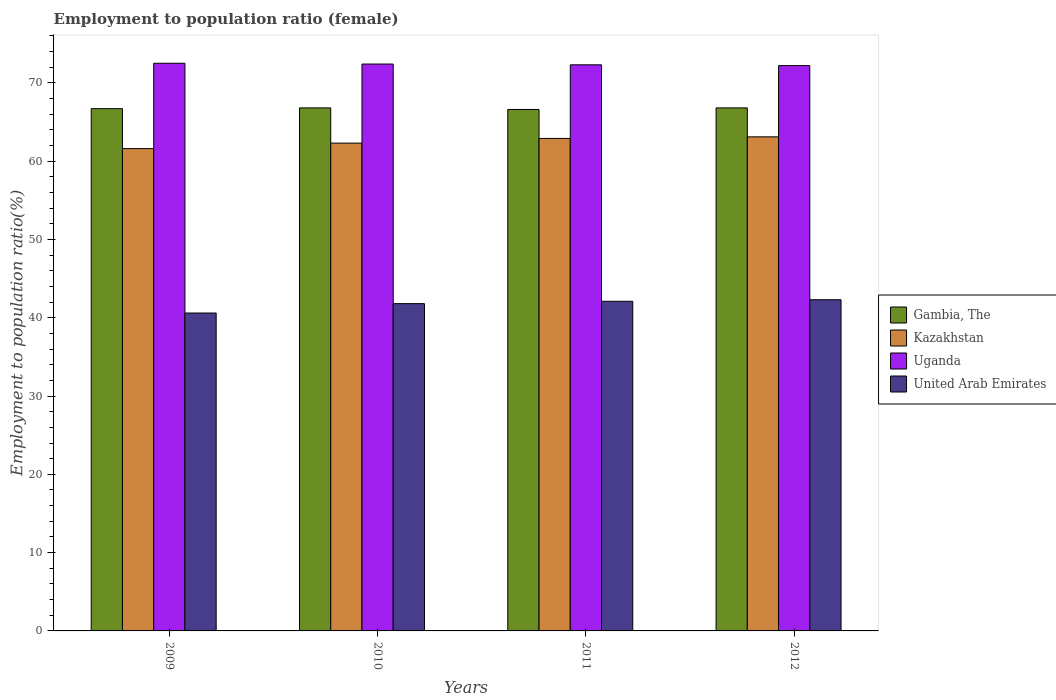How many different coloured bars are there?
Offer a very short reply. 4. Are the number of bars per tick equal to the number of legend labels?
Provide a succinct answer. Yes. Are the number of bars on each tick of the X-axis equal?
Provide a short and direct response. Yes. How many bars are there on the 2nd tick from the left?
Provide a short and direct response. 4. How many bars are there on the 4th tick from the right?
Provide a short and direct response. 4. What is the label of the 4th group of bars from the left?
Give a very brief answer. 2012. In how many cases, is the number of bars for a given year not equal to the number of legend labels?
Your answer should be very brief. 0. What is the employment to population ratio in United Arab Emirates in 2010?
Offer a very short reply. 41.8. Across all years, what is the maximum employment to population ratio in Uganda?
Provide a short and direct response. 72.5. Across all years, what is the minimum employment to population ratio in Kazakhstan?
Make the answer very short. 61.6. What is the total employment to population ratio in United Arab Emirates in the graph?
Your answer should be very brief. 166.8. What is the difference between the employment to population ratio in Kazakhstan in 2010 and that in 2012?
Make the answer very short. -0.8. What is the difference between the employment to population ratio in United Arab Emirates in 2009 and the employment to population ratio in Kazakhstan in 2012?
Provide a succinct answer. -22.5. What is the average employment to population ratio in Uganda per year?
Your response must be concise. 72.35. In the year 2011, what is the difference between the employment to population ratio in Gambia, The and employment to population ratio in Uganda?
Ensure brevity in your answer.  -5.7. In how many years, is the employment to population ratio in Uganda greater than 46 %?
Offer a terse response. 4. What is the ratio of the employment to population ratio in Gambia, The in 2009 to that in 2012?
Make the answer very short. 1. Is the difference between the employment to population ratio in Gambia, The in 2009 and 2011 greater than the difference between the employment to population ratio in Uganda in 2009 and 2011?
Provide a succinct answer. No. What is the difference between the highest and the second highest employment to population ratio in Uganda?
Ensure brevity in your answer.  0.1. What is the difference between the highest and the lowest employment to population ratio in United Arab Emirates?
Provide a short and direct response. 1.7. In how many years, is the employment to population ratio in United Arab Emirates greater than the average employment to population ratio in United Arab Emirates taken over all years?
Ensure brevity in your answer.  3. What does the 4th bar from the left in 2011 represents?
Your response must be concise. United Arab Emirates. What does the 4th bar from the right in 2012 represents?
Provide a short and direct response. Gambia, The. How many bars are there?
Your answer should be compact. 16. Are all the bars in the graph horizontal?
Make the answer very short. No. How many years are there in the graph?
Ensure brevity in your answer.  4. What is the difference between two consecutive major ticks on the Y-axis?
Make the answer very short. 10. Does the graph contain any zero values?
Provide a succinct answer. No. Does the graph contain grids?
Your answer should be very brief. No. Where does the legend appear in the graph?
Provide a short and direct response. Center right. How many legend labels are there?
Ensure brevity in your answer.  4. How are the legend labels stacked?
Make the answer very short. Vertical. What is the title of the graph?
Offer a terse response. Employment to population ratio (female). Does "Morocco" appear as one of the legend labels in the graph?
Offer a terse response. No. What is the Employment to population ratio(%) of Gambia, The in 2009?
Your answer should be very brief. 66.7. What is the Employment to population ratio(%) of Kazakhstan in 2009?
Offer a terse response. 61.6. What is the Employment to population ratio(%) of Uganda in 2009?
Your response must be concise. 72.5. What is the Employment to population ratio(%) of United Arab Emirates in 2009?
Give a very brief answer. 40.6. What is the Employment to population ratio(%) of Gambia, The in 2010?
Your answer should be compact. 66.8. What is the Employment to population ratio(%) of Kazakhstan in 2010?
Provide a succinct answer. 62.3. What is the Employment to population ratio(%) in Uganda in 2010?
Make the answer very short. 72.4. What is the Employment to population ratio(%) of United Arab Emirates in 2010?
Keep it short and to the point. 41.8. What is the Employment to population ratio(%) in Gambia, The in 2011?
Keep it short and to the point. 66.6. What is the Employment to population ratio(%) of Kazakhstan in 2011?
Keep it short and to the point. 62.9. What is the Employment to population ratio(%) of Uganda in 2011?
Give a very brief answer. 72.3. What is the Employment to population ratio(%) in United Arab Emirates in 2011?
Offer a terse response. 42.1. What is the Employment to population ratio(%) in Gambia, The in 2012?
Your answer should be compact. 66.8. What is the Employment to population ratio(%) of Kazakhstan in 2012?
Your response must be concise. 63.1. What is the Employment to population ratio(%) of Uganda in 2012?
Your answer should be compact. 72.2. What is the Employment to population ratio(%) in United Arab Emirates in 2012?
Keep it short and to the point. 42.3. Across all years, what is the maximum Employment to population ratio(%) of Gambia, The?
Offer a very short reply. 66.8. Across all years, what is the maximum Employment to population ratio(%) in Kazakhstan?
Your answer should be compact. 63.1. Across all years, what is the maximum Employment to population ratio(%) in Uganda?
Offer a terse response. 72.5. Across all years, what is the maximum Employment to population ratio(%) in United Arab Emirates?
Provide a short and direct response. 42.3. Across all years, what is the minimum Employment to population ratio(%) in Gambia, The?
Keep it short and to the point. 66.6. Across all years, what is the minimum Employment to population ratio(%) of Kazakhstan?
Offer a very short reply. 61.6. Across all years, what is the minimum Employment to population ratio(%) in Uganda?
Your response must be concise. 72.2. Across all years, what is the minimum Employment to population ratio(%) in United Arab Emirates?
Give a very brief answer. 40.6. What is the total Employment to population ratio(%) of Gambia, The in the graph?
Offer a terse response. 266.9. What is the total Employment to population ratio(%) of Kazakhstan in the graph?
Offer a very short reply. 249.9. What is the total Employment to population ratio(%) in Uganda in the graph?
Your answer should be very brief. 289.4. What is the total Employment to population ratio(%) of United Arab Emirates in the graph?
Give a very brief answer. 166.8. What is the difference between the Employment to population ratio(%) of Gambia, The in 2009 and that in 2010?
Keep it short and to the point. -0.1. What is the difference between the Employment to population ratio(%) in Uganda in 2009 and that in 2010?
Make the answer very short. 0.1. What is the difference between the Employment to population ratio(%) in Gambia, The in 2009 and that in 2011?
Provide a succinct answer. 0.1. What is the difference between the Employment to population ratio(%) of Kazakhstan in 2009 and that in 2011?
Make the answer very short. -1.3. What is the difference between the Employment to population ratio(%) of Uganda in 2009 and that in 2011?
Ensure brevity in your answer.  0.2. What is the difference between the Employment to population ratio(%) of Uganda in 2009 and that in 2012?
Offer a very short reply. 0.3. What is the difference between the Employment to population ratio(%) in United Arab Emirates in 2009 and that in 2012?
Your answer should be very brief. -1.7. What is the difference between the Employment to population ratio(%) of Gambia, The in 2010 and that in 2011?
Make the answer very short. 0.2. What is the difference between the Employment to population ratio(%) of Kazakhstan in 2010 and that in 2011?
Provide a short and direct response. -0.6. What is the difference between the Employment to population ratio(%) of Gambia, The in 2010 and that in 2012?
Give a very brief answer. 0. What is the difference between the Employment to population ratio(%) of Uganda in 2010 and that in 2012?
Offer a terse response. 0.2. What is the difference between the Employment to population ratio(%) of Gambia, The in 2009 and the Employment to population ratio(%) of Kazakhstan in 2010?
Your answer should be compact. 4.4. What is the difference between the Employment to population ratio(%) in Gambia, The in 2009 and the Employment to population ratio(%) in Uganda in 2010?
Give a very brief answer. -5.7. What is the difference between the Employment to population ratio(%) of Gambia, The in 2009 and the Employment to population ratio(%) of United Arab Emirates in 2010?
Ensure brevity in your answer.  24.9. What is the difference between the Employment to population ratio(%) of Kazakhstan in 2009 and the Employment to population ratio(%) of United Arab Emirates in 2010?
Make the answer very short. 19.8. What is the difference between the Employment to population ratio(%) in Uganda in 2009 and the Employment to population ratio(%) in United Arab Emirates in 2010?
Ensure brevity in your answer.  30.7. What is the difference between the Employment to population ratio(%) in Gambia, The in 2009 and the Employment to population ratio(%) in Kazakhstan in 2011?
Provide a succinct answer. 3.8. What is the difference between the Employment to population ratio(%) of Gambia, The in 2009 and the Employment to population ratio(%) of United Arab Emirates in 2011?
Your response must be concise. 24.6. What is the difference between the Employment to population ratio(%) in Kazakhstan in 2009 and the Employment to population ratio(%) in United Arab Emirates in 2011?
Give a very brief answer. 19.5. What is the difference between the Employment to population ratio(%) in Uganda in 2009 and the Employment to population ratio(%) in United Arab Emirates in 2011?
Your answer should be very brief. 30.4. What is the difference between the Employment to population ratio(%) in Gambia, The in 2009 and the Employment to population ratio(%) in Kazakhstan in 2012?
Make the answer very short. 3.6. What is the difference between the Employment to population ratio(%) in Gambia, The in 2009 and the Employment to population ratio(%) in Uganda in 2012?
Offer a very short reply. -5.5. What is the difference between the Employment to population ratio(%) in Gambia, The in 2009 and the Employment to population ratio(%) in United Arab Emirates in 2012?
Provide a succinct answer. 24.4. What is the difference between the Employment to population ratio(%) in Kazakhstan in 2009 and the Employment to population ratio(%) in Uganda in 2012?
Keep it short and to the point. -10.6. What is the difference between the Employment to population ratio(%) in Kazakhstan in 2009 and the Employment to population ratio(%) in United Arab Emirates in 2012?
Offer a terse response. 19.3. What is the difference between the Employment to population ratio(%) in Uganda in 2009 and the Employment to population ratio(%) in United Arab Emirates in 2012?
Make the answer very short. 30.2. What is the difference between the Employment to population ratio(%) in Gambia, The in 2010 and the Employment to population ratio(%) in Kazakhstan in 2011?
Your response must be concise. 3.9. What is the difference between the Employment to population ratio(%) in Gambia, The in 2010 and the Employment to population ratio(%) in United Arab Emirates in 2011?
Make the answer very short. 24.7. What is the difference between the Employment to population ratio(%) in Kazakhstan in 2010 and the Employment to population ratio(%) in United Arab Emirates in 2011?
Keep it short and to the point. 20.2. What is the difference between the Employment to population ratio(%) of Uganda in 2010 and the Employment to population ratio(%) of United Arab Emirates in 2011?
Provide a succinct answer. 30.3. What is the difference between the Employment to population ratio(%) in Gambia, The in 2010 and the Employment to population ratio(%) in Kazakhstan in 2012?
Offer a terse response. 3.7. What is the difference between the Employment to population ratio(%) in Gambia, The in 2010 and the Employment to population ratio(%) in Uganda in 2012?
Your answer should be compact. -5.4. What is the difference between the Employment to population ratio(%) in Kazakhstan in 2010 and the Employment to population ratio(%) in Uganda in 2012?
Ensure brevity in your answer.  -9.9. What is the difference between the Employment to population ratio(%) in Kazakhstan in 2010 and the Employment to population ratio(%) in United Arab Emirates in 2012?
Your response must be concise. 20. What is the difference between the Employment to population ratio(%) of Uganda in 2010 and the Employment to population ratio(%) of United Arab Emirates in 2012?
Offer a terse response. 30.1. What is the difference between the Employment to population ratio(%) of Gambia, The in 2011 and the Employment to population ratio(%) of United Arab Emirates in 2012?
Offer a terse response. 24.3. What is the difference between the Employment to population ratio(%) in Kazakhstan in 2011 and the Employment to population ratio(%) in Uganda in 2012?
Provide a succinct answer. -9.3. What is the difference between the Employment to population ratio(%) in Kazakhstan in 2011 and the Employment to population ratio(%) in United Arab Emirates in 2012?
Your answer should be very brief. 20.6. What is the average Employment to population ratio(%) in Gambia, The per year?
Keep it short and to the point. 66.72. What is the average Employment to population ratio(%) in Kazakhstan per year?
Your response must be concise. 62.48. What is the average Employment to population ratio(%) of Uganda per year?
Give a very brief answer. 72.35. What is the average Employment to population ratio(%) of United Arab Emirates per year?
Your response must be concise. 41.7. In the year 2009, what is the difference between the Employment to population ratio(%) of Gambia, The and Employment to population ratio(%) of Kazakhstan?
Give a very brief answer. 5.1. In the year 2009, what is the difference between the Employment to population ratio(%) of Gambia, The and Employment to population ratio(%) of Uganda?
Provide a short and direct response. -5.8. In the year 2009, what is the difference between the Employment to population ratio(%) in Gambia, The and Employment to population ratio(%) in United Arab Emirates?
Offer a terse response. 26.1. In the year 2009, what is the difference between the Employment to population ratio(%) of Kazakhstan and Employment to population ratio(%) of Uganda?
Give a very brief answer. -10.9. In the year 2009, what is the difference between the Employment to population ratio(%) in Uganda and Employment to population ratio(%) in United Arab Emirates?
Offer a terse response. 31.9. In the year 2010, what is the difference between the Employment to population ratio(%) of Kazakhstan and Employment to population ratio(%) of Uganda?
Ensure brevity in your answer.  -10.1. In the year 2010, what is the difference between the Employment to population ratio(%) of Uganda and Employment to population ratio(%) of United Arab Emirates?
Give a very brief answer. 30.6. In the year 2011, what is the difference between the Employment to population ratio(%) of Gambia, The and Employment to population ratio(%) of Uganda?
Give a very brief answer. -5.7. In the year 2011, what is the difference between the Employment to population ratio(%) of Gambia, The and Employment to population ratio(%) of United Arab Emirates?
Your answer should be very brief. 24.5. In the year 2011, what is the difference between the Employment to population ratio(%) in Kazakhstan and Employment to population ratio(%) in Uganda?
Offer a terse response. -9.4. In the year 2011, what is the difference between the Employment to population ratio(%) in Kazakhstan and Employment to population ratio(%) in United Arab Emirates?
Your answer should be compact. 20.8. In the year 2011, what is the difference between the Employment to population ratio(%) in Uganda and Employment to population ratio(%) in United Arab Emirates?
Ensure brevity in your answer.  30.2. In the year 2012, what is the difference between the Employment to population ratio(%) in Gambia, The and Employment to population ratio(%) in Kazakhstan?
Keep it short and to the point. 3.7. In the year 2012, what is the difference between the Employment to population ratio(%) of Gambia, The and Employment to population ratio(%) of Uganda?
Provide a short and direct response. -5.4. In the year 2012, what is the difference between the Employment to population ratio(%) in Kazakhstan and Employment to population ratio(%) in United Arab Emirates?
Keep it short and to the point. 20.8. In the year 2012, what is the difference between the Employment to population ratio(%) of Uganda and Employment to population ratio(%) of United Arab Emirates?
Make the answer very short. 29.9. What is the ratio of the Employment to population ratio(%) of Gambia, The in 2009 to that in 2010?
Make the answer very short. 1. What is the ratio of the Employment to population ratio(%) in Kazakhstan in 2009 to that in 2010?
Provide a succinct answer. 0.99. What is the ratio of the Employment to population ratio(%) in United Arab Emirates in 2009 to that in 2010?
Your answer should be compact. 0.97. What is the ratio of the Employment to population ratio(%) of Gambia, The in 2009 to that in 2011?
Give a very brief answer. 1. What is the ratio of the Employment to population ratio(%) of Kazakhstan in 2009 to that in 2011?
Your answer should be very brief. 0.98. What is the ratio of the Employment to population ratio(%) in Uganda in 2009 to that in 2011?
Your response must be concise. 1. What is the ratio of the Employment to population ratio(%) of United Arab Emirates in 2009 to that in 2011?
Your answer should be very brief. 0.96. What is the ratio of the Employment to population ratio(%) of Kazakhstan in 2009 to that in 2012?
Ensure brevity in your answer.  0.98. What is the ratio of the Employment to population ratio(%) of Uganda in 2009 to that in 2012?
Provide a short and direct response. 1. What is the ratio of the Employment to population ratio(%) of United Arab Emirates in 2009 to that in 2012?
Provide a succinct answer. 0.96. What is the ratio of the Employment to population ratio(%) of Gambia, The in 2010 to that in 2011?
Offer a terse response. 1. What is the ratio of the Employment to population ratio(%) of Kazakhstan in 2010 to that in 2011?
Offer a terse response. 0.99. What is the ratio of the Employment to population ratio(%) of Kazakhstan in 2010 to that in 2012?
Provide a succinct answer. 0.99. What is the ratio of the Employment to population ratio(%) in Uganda in 2010 to that in 2012?
Offer a terse response. 1. What is the ratio of the Employment to population ratio(%) in United Arab Emirates in 2010 to that in 2012?
Give a very brief answer. 0.99. What is the ratio of the Employment to population ratio(%) in Kazakhstan in 2011 to that in 2012?
Give a very brief answer. 1. What is the difference between the highest and the second highest Employment to population ratio(%) in Gambia, The?
Your response must be concise. 0. What is the difference between the highest and the lowest Employment to population ratio(%) of Gambia, The?
Keep it short and to the point. 0.2. What is the difference between the highest and the lowest Employment to population ratio(%) of Uganda?
Offer a very short reply. 0.3. What is the difference between the highest and the lowest Employment to population ratio(%) of United Arab Emirates?
Make the answer very short. 1.7. 